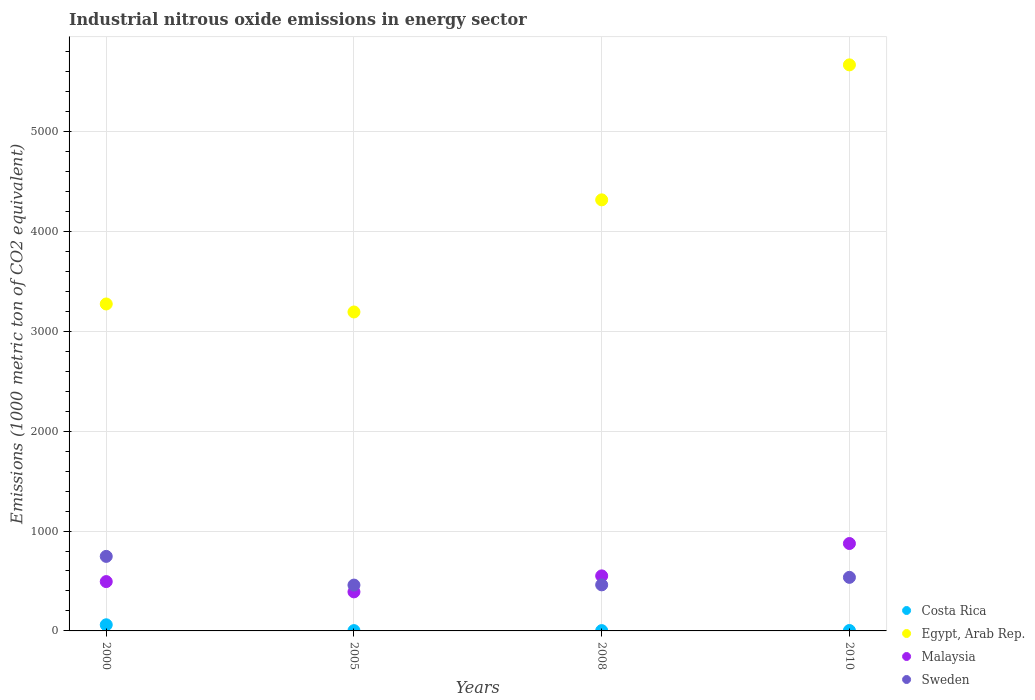How many different coloured dotlines are there?
Provide a short and direct response. 4. What is the amount of industrial nitrous oxide emitted in Egypt, Arab Rep. in 2005?
Offer a very short reply. 3192.6. Across all years, what is the maximum amount of industrial nitrous oxide emitted in Malaysia?
Ensure brevity in your answer.  874.9. Across all years, what is the minimum amount of industrial nitrous oxide emitted in Malaysia?
Provide a short and direct response. 390.9. In which year was the amount of industrial nitrous oxide emitted in Costa Rica minimum?
Your response must be concise. 2005. What is the total amount of industrial nitrous oxide emitted in Malaysia in the graph?
Offer a terse response. 2310.6. What is the difference between the amount of industrial nitrous oxide emitted in Egypt, Arab Rep. in 2000 and that in 2010?
Your answer should be very brief. -2393.5. What is the difference between the amount of industrial nitrous oxide emitted in Egypt, Arab Rep. in 2000 and the amount of industrial nitrous oxide emitted in Costa Rica in 2005?
Provide a short and direct response. 3269.6. What is the average amount of industrial nitrous oxide emitted in Sweden per year?
Your response must be concise. 550.55. In the year 2000, what is the difference between the amount of industrial nitrous oxide emitted in Egypt, Arab Rep. and amount of industrial nitrous oxide emitted in Sweden?
Ensure brevity in your answer.  2526.6. What is the ratio of the amount of industrial nitrous oxide emitted in Sweden in 2005 to that in 2010?
Offer a very short reply. 0.86. Is the amount of industrial nitrous oxide emitted in Sweden in 2000 less than that in 2005?
Offer a terse response. No. What is the difference between the highest and the second highest amount of industrial nitrous oxide emitted in Malaysia?
Offer a very short reply. 323.9. What is the difference between the highest and the lowest amount of industrial nitrous oxide emitted in Egypt, Arab Rep.?
Offer a terse response. 2473.6. Does the amount of industrial nitrous oxide emitted in Sweden monotonically increase over the years?
Make the answer very short. No. Is the amount of industrial nitrous oxide emitted in Costa Rica strictly greater than the amount of industrial nitrous oxide emitted in Egypt, Arab Rep. over the years?
Offer a terse response. No. What is the difference between two consecutive major ticks on the Y-axis?
Provide a succinct answer. 1000. Are the values on the major ticks of Y-axis written in scientific E-notation?
Ensure brevity in your answer.  No. Does the graph contain grids?
Make the answer very short. Yes. How are the legend labels stacked?
Your response must be concise. Vertical. What is the title of the graph?
Your response must be concise. Industrial nitrous oxide emissions in energy sector. What is the label or title of the Y-axis?
Give a very brief answer. Emissions (1000 metric ton of CO2 equivalent). What is the Emissions (1000 metric ton of CO2 equivalent) of Costa Rica in 2000?
Ensure brevity in your answer.  61.4. What is the Emissions (1000 metric ton of CO2 equivalent) of Egypt, Arab Rep. in 2000?
Give a very brief answer. 3272.7. What is the Emissions (1000 metric ton of CO2 equivalent) of Malaysia in 2000?
Provide a succinct answer. 493.8. What is the Emissions (1000 metric ton of CO2 equivalent) in Sweden in 2000?
Your answer should be very brief. 746.1. What is the Emissions (1000 metric ton of CO2 equivalent) of Egypt, Arab Rep. in 2005?
Your response must be concise. 3192.6. What is the Emissions (1000 metric ton of CO2 equivalent) of Malaysia in 2005?
Ensure brevity in your answer.  390.9. What is the Emissions (1000 metric ton of CO2 equivalent) in Sweden in 2005?
Give a very brief answer. 458.8. What is the Emissions (1000 metric ton of CO2 equivalent) in Egypt, Arab Rep. in 2008?
Keep it short and to the point. 4315. What is the Emissions (1000 metric ton of CO2 equivalent) in Malaysia in 2008?
Give a very brief answer. 551. What is the Emissions (1000 metric ton of CO2 equivalent) in Sweden in 2008?
Ensure brevity in your answer.  461.1. What is the Emissions (1000 metric ton of CO2 equivalent) in Costa Rica in 2010?
Give a very brief answer. 4.2. What is the Emissions (1000 metric ton of CO2 equivalent) in Egypt, Arab Rep. in 2010?
Keep it short and to the point. 5666.2. What is the Emissions (1000 metric ton of CO2 equivalent) in Malaysia in 2010?
Provide a succinct answer. 874.9. What is the Emissions (1000 metric ton of CO2 equivalent) of Sweden in 2010?
Ensure brevity in your answer.  536.2. Across all years, what is the maximum Emissions (1000 metric ton of CO2 equivalent) in Costa Rica?
Offer a terse response. 61.4. Across all years, what is the maximum Emissions (1000 metric ton of CO2 equivalent) of Egypt, Arab Rep.?
Keep it short and to the point. 5666.2. Across all years, what is the maximum Emissions (1000 metric ton of CO2 equivalent) in Malaysia?
Make the answer very short. 874.9. Across all years, what is the maximum Emissions (1000 metric ton of CO2 equivalent) in Sweden?
Provide a succinct answer. 746.1. Across all years, what is the minimum Emissions (1000 metric ton of CO2 equivalent) of Egypt, Arab Rep.?
Your answer should be compact. 3192.6. Across all years, what is the minimum Emissions (1000 metric ton of CO2 equivalent) in Malaysia?
Offer a very short reply. 390.9. Across all years, what is the minimum Emissions (1000 metric ton of CO2 equivalent) of Sweden?
Keep it short and to the point. 458.8. What is the total Emissions (1000 metric ton of CO2 equivalent) in Costa Rica in the graph?
Offer a very short reply. 71.8. What is the total Emissions (1000 metric ton of CO2 equivalent) of Egypt, Arab Rep. in the graph?
Your answer should be compact. 1.64e+04. What is the total Emissions (1000 metric ton of CO2 equivalent) in Malaysia in the graph?
Offer a terse response. 2310.6. What is the total Emissions (1000 metric ton of CO2 equivalent) in Sweden in the graph?
Keep it short and to the point. 2202.2. What is the difference between the Emissions (1000 metric ton of CO2 equivalent) of Costa Rica in 2000 and that in 2005?
Give a very brief answer. 58.3. What is the difference between the Emissions (1000 metric ton of CO2 equivalent) in Egypt, Arab Rep. in 2000 and that in 2005?
Make the answer very short. 80.1. What is the difference between the Emissions (1000 metric ton of CO2 equivalent) in Malaysia in 2000 and that in 2005?
Make the answer very short. 102.9. What is the difference between the Emissions (1000 metric ton of CO2 equivalent) in Sweden in 2000 and that in 2005?
Your response must be concise. 287.3. What is the difference between the Emissions (1000 metric ton of CO2 equivalent) in Costa Rica in 2000 and that in 2008?
Your answer should be compact. 58.3. What is the difference between the Emissions (1000 metric ton of CO2 equivalent) in Egypt, Arab Rep. in 2000 and that in 2008?
Make the answer very short. -1042.3. What is the difference between the Emissions (1000 metric ton of CO2 equivalent) of Malaysia in 2000 and that in 2008?
Keep it short and to the point. -57.2. What is the difference between the Emissions (1000 metric ton of CO2 equivalent) of Sweden in 2000 and that in 2008?
Your response must be concise. 285. What is the difference between the Emissions (1000 metric ton of CO2 equivalent) in Costa Rica in 2000 and that in 2010?
Ensure brevity in your answer.  57.2. What is the difference between the Emissions (1000 metric ton of CO2 equivalent) of Egypt, Arab Rep. in 2000 and that in 2010?
Offer a very short reply. -2393.5. What is the difference between the Emissions (1000 metric ton of CO2 equivalent) of Malaysia in 2000 and that in 2010?
Your response must be concise. -381.1. What is the difference between the Emissions (1000 metric ton of CO2 equivalent) of Sweden in 2000 and that in 2010?
Offer a very short reply. 209.9. What is the difference between the Emissions (1000 metric ton of CO2 equivalent) in Costa Rica in 2005 and that in 2008?
Offer a very short reply. 0. What is the difference between the Emissions (1000 metric ton of CO2 equivalent) in Egypt, Arab Rep. in 2005 and that in 2008?
Provide a succinct answer. -1122.4. What is the difference between the Emissions (1000 metric ton of CO2 equivalent) in Malaysia in 2005 and that in 2008?
Your response must be concise. -160.1. What is the difference between the Emissions (1000 metric ton of CO2 equivalent) of Sweden in 2005 and that in 2008?
Ensure brevity in your answer.  -2.3. What is the difference between the Emissions (1000 metric ton of CO2 equivalent) of Egypt, Arab Rep. in 2005 and that in 2010?
Provide a short and direct response. -2473.6. What is the difference between the Emissions (1000 metric ton of CO2 equivalent) of Malaysia in 2005 and that in 2010?
Your response must be concise. -484. What is the difference between the Emissions (1000 metric ton of CO2 equivalent) in Sweden in 2005 and that in 2010?
Your answer should be very brief. -77.4. What is the difference between the Emissions (1000 metric ton of CO2 equivalent) in Costa Rica in 2008 and that in 2010?
Make the answer very short. -1.1. What is the difference between the Emissions (1000 metric ton of CO2 equivalent) of Egypt, Arab Rep. in 2008 and that in 2010?
Ensure brevity in your answer.  -1351.2. What is the difference between the Emissions (1000 metric ton of CO2 equivalent) in Malaysia in 2008 and that in 2010?
Provide a short and direct response. -323.9. What is the difference between the Emissions (1000 metric ton of CO2 equivalent) in Sweden in 2008 and that in 2010?
Offer a terse response. -75.1. What is the difference between the Emissions (1000 metric ton of CO2 equivalent) of Costa Rica in 2000 and the Emissions (1000 metric ton of CO2 equivalent) of Egypt, Arab Rep. in 2005?
Provide a short and direct response. -3131.2. What is the difference between the Emissions (1000 metric ton of CO2 equivalent) of Costa Rica in 2000 and the Emissions (1000 metric ton of CO2 equivalent) of Malaysia in 2005?
Your answer should be compact. -329.5. What is the difference between the Emissions (1000 metric ton of CO2 equivalent) of Costa Rica in 2000 and the Emissions (1000 metric ton of CO2 equivalent) of Sweden in 2005?
Your response must be concise. -397.4. What is the difference between the Emissions (1000 metric ton of CO2 equivalent) of Egypt, Arab Rep. in 2000 and the Emissions (1000 metric ton of CO2 equivalent) of Malaysia in 2005?
Give a very brief answer. 2881.8. What is the difference between the Emissions (1000 metric ton of CO2 equivalent) of Egypt, Arab Rep. in 2000 and the Emissions (1000 metric ton of CO2 equivalent) of Sweden in 2005?
Ensure brevity in your answer.  2813.9. What is the difference between the Emissions (1000 metric ton of CO2 equivalent) in Malaysia in 2000 and the Emissions (1000 metric ton of CO2 equivalent) in Sweden in 2005?
Provide a succinct answer. 35. What is the difference between the Emissions (1000 metric ton of CO2 equivalent) of Costa Rica in 2000 and the Emissions (1000 metric ton of CO2 equivalent) of Egypt, Arab Rep. in 2008?
Offer a very short reply. -4253.6. What is the difference between the Emissions (1000 metric ton of CO2 equivalent) in Costa Rica in 2000 and the Emissions (1000 metric ton of CO2 equivalent) in Malaysia in 2008?
Give a very brief answer. -489.6. What is the difference between the Emissions (1000 metric ton of CO2 equivalent) of Costa Rica in 2000 and the Emissions (1000 metric ton of CO2 equivalent) of Sweden in 2008?
Your answer should be very brief. -399.7. What is the difference between the Emissions (1000 metric ton of CO2 equivalent) in Egypt, Arab Rep. in 2000 and the Emissions (1000 metric ton of CO2 equivalent) in Malaysia in 2008?
Provide a short and direct response. 2721.7. What is the difference between the Emissions (1000 metric ton of CO2 equivalent) in Egypt, Arab Rep. in 2000 and the Emissions (1000 metric ton of CO2 equivalent) in Sweden in 2008?
Ensure brevity in your answer.  2811.6. What is the difference between the Emissions (1000 metric ton of CO2 equivalent) in Malaysia in 2000 and the Emissions (1000 metric ton of CO2 equivalent) in Sweden in 2008?
Your response must be concise. 32.7. What is the difference between the Emissions (1000 metric ton of CO2 equivalent) in Costa Rica in 2000 and the Emissions (1000 metric ton of CO2 equivalent) in Egypt, Arab Rep. in 2010?
Offer a terse response. -5604.8. What is the difference between the Emissions (1000 metric ton of CO2 equivalent) in Costa Rica in 2000 and the Emissions (1000 metric ton of CO2 equivalent) in Malaysia in 2010?
Offer a very short reply. -813.5. What is the difference between the Emissions (1000 metric ton of CO2 equivalent) in Costa Rica in 2000 and the Emissions (1000 metric ton of CO2 equivalent) in Sweden in 2010?
Your answer should be compact. -474.8. What is the difference between the Emissions (1000 metric ton of CO2 equivalent) in Egypt, Arab Rep. in 2000 and the Emissions (1000 metric ton of CO2 equivalent) in Malaysia in 2010?
Give a very brief answer. 2397.8. What is the difference between the Emissions (1000 metric ton of CO2 equivalent) of Egypt, Arab Rep. in 2000 and the Emissions (1000 metric ton of CO2 equivalent) of Sweden in 2010?
Your answer should be compact. 2736.5. What is the difference between the Emissions (1000 metric ton of CO2 equivalent) in Malaysia in 2000 and the Emissions (1000 metric ton of CO2 equivalent) in Sweden in 2010?
Offer a very short reply. -42.4. What is the difference between the Emissions (1000 metric ton of CO2 equivalent) of Costa Rica in 2005 and the Emissions (1000 metric ton of CO2 equivalent) of Egypt, Arab Rep. in 2008?
Make the answer very short. -4311.9. What is the difference between the Emissions (1000 metric ton of CO2 equivalent) of Costa Rica in 2005 and the Emissions (1000 metric ton of CO2 equivalent) of Malaysia in 2008?
Ensure brevity in your answer.  -547.9. What is the difference between the Emissions (1000 metric ton of CO2 equivalent) in Costa Rica in 2005 and the Emissions (1000 metric ton of CO2 equivalent) in Sweden in 2008?
Offer a very short reply. -458. What is the difference between the Emissions (1000 metric ton of CO2 equivalent) of Egypt, Arab Rep. in 2005 and the Emissions (1000 metric ton of CO2 equivalent) of Malaysia in 2008?
Give a very brief answer. 2641.6. What is the difference between the Emissions (1000 metric ton of CO2 equivalent) in Egypt, Arab Rep. in 2005 and the Emissions (1000 metric ton of CO2 equivalent) in Sweden in 2008?
Give a very brief answer. 2731.5. What is the difference between the Emissions (1000 metric ton of CO2 equivalent) in Malaysia in 2005 and the Emissions (1000 metric ton of CO2 equivalent) in Sweden in 2008?
Keep it short and to the point. -70.2. What is the difference between the Emissions (1000 metric ton of CO2 equivalent) in Costa Rica in 2005 and the Emissions (1000 metric ton of CO2 equivalent) in Egypt, Arab Rep. in 2010?
Offer a very short reply. -5663.1. What is the difference between the Emissions (1000 metric ton of CO2 equivalent) of Costa Rica in 2005 and the Emissions (1000 metric ton of CO2 equivalent) of Malaysia in 2010?
Your answer should be compact. -871.8. What is the difference between the Emissions (1000 metric ton of CO2 equivalent) of Costa Rica in 2005 and the Emissions (1000 metric ton of CO2 equivalent) of Sweden in 2010?
Your answer should be very brief. -533.1. What is the difference between the Emissions (1000 metric ton of CO2 equivalent) of Egypt, Arab Rep. in 2005 and the Emissions (1000 metric ton of CO2 equivalent) of Malaysia in 2010?
Keep it short and to the point. 2317.7. What is the difference between the Emissions (1000 metric ton of CO2 equivalent) of Egypt, Arab Rep. in 2005 and the Emissions (1000 metric ton of CO2 equivalent) of Sweden in 2010?
Keep it short and to the point. 2656.4. What is the difference between the Emissions (1000 metric ton of CO2 equivalent) in Malaysia in 2005 and the Emissions (1000 metric ton of CO2 equivalent) in Sweden in 2010?
Give a very brief answer. -145.3. What is the difference between the Emissions (1000 metric ton of CO2 equivalent) of Costa Rica in 2008 and the Emissions (1000 metric ton of CO2 equivalent) of Egypt, Arab Rep. in 2010?
Give a very brief answer. -5663.1. What is the difference between the Emissions (1000 metric ton of CO2 equivalent) of Costa Rica in 2008 and the Emissions (1000 metric ton of CO2 equivalent) of Malaysia in 2010?
Your response must be concise. -871.8. What is the difference between the Emissions (1000 metric ton of CO2 equivalent) in Costa Rica in 2008 and the Emissions (1000 metric ton of CO2 equivalent) in Sweden in 2010?
Your answer should be very brief. -533.1. What is the difference between the Emissions (1000 metric ton of CO2 equivalent) of Egypt, Arab Rep. in 2008 and the Emissions (1000 metric ton of CO2 equivalent) of Malaysia in 2010?
Provide a short and direct response. 3440.1. What is the difference between the Emissions (1000 metric ton of CO2 equivalent) of Egypt, Arab Rep. in 2008 and the Emissions (1000 metric ton of CO2 equivalent) of Sweden in 2010?
Keep it short and to the point. 3778.8. What is the average Emissions (1000 metric ton of CO2 equivalent) in Costa Rica per year?
Offer a terse response. 17.95. What is the average Emissions (1000 metric ton of CO2 equivalent) of Egypt, Arab Rep. per year?
Your response must be concise. 4111.62. What is the average Emissions (1000 metric ton of CO2 equivalent) of Malaysia per year?
Keep it short and to the point. 577.65. What is the average Emissions (1000 metric ton of CO2 equivalent) in Sweden per year?
Keep it short and to the point. 550.55. In the year 2000, what is the difference between the Emissions (1000 metric ton of CO2 equivalent) of Costa Rica and Emissions (1000 metric ton of CO2 equivalent) of Egypt, Arab Rep.?
Ensure brevity in your answer.  -3211.3. In the year 2000, what is the difference between the Emissions (1000 metric ton of CO2 equivalent) of Costa Rica and Emissions (1000 metric ton of CO2 equivalent) of Malaysia?
Your answer should be very brief. -432.4. In the year 2000, what is the difference between the Emissions (1000 metric ton of CO2 equivalent) in Costa Rica and Emissions (1000 metric ton of CO2 equivalent) in Sweden?
Ensure brevity in your answer.  -684.7. In the year 2000, what is the difference between the Emissions (1000 metric ton of CO2 equivalent) in Egypt, Arab Rep. and Emissions (1000 metric ton of CO2 equivalent) in Malaysia?
Provide a succinct answer. 2778.9. In the year 2000, what is the difference between the Emissions (1000 metric ton of CO2 equivalent) in Egypt, Arab Rep. and Emissions (1000 metric ton of CO2 equivalent) in Sweden?
Provide a short and direct response. 2526.6. In the year 2000, what is the difference between the Emissions (1000 metric ton of CO2 equivalent) of Malaysia and Emissions (1000 metric ton of CO2 equivalent) of Sweden?
Your response must be concise. -252.3. In the year 2005, what is the difference between the Emissions (1000 metric ton of CO2 equivalent) in Costa Rica and Emissions (1000 metric ton of CO2 equivalent) in Egypt, Arab Rep.?
Your response must be concise. -3189.5. In the year 2005, what is the difference between the Emissions (1000 metric ton of CO2 equivalent) in Costa Rica and Emissions (1000 metric ton of CO2 equivalent) in Malaysia?
Keep it short and to the point. -387.8. In the year 2005, what is the difference between the Emissions (1000 metric ton of CO2 equivalent) of Costa Rica and Emissions (1000 metric ton of CO2 equivalent) of Sweden?
Your response must be concise. -455.7. In the year 2005, what is the difference between the Emissions (1000 metric ton of CO2 equivalent) in Egypt, Arab Rep. and Emissions (1000 metric ton of CO2 equivalent) in Malaysia?
Give a very brief answer. 2801.7. In the year 2005, what is the difference between the Emissions (1000 metric ton of CO2 equivalent) of Egypt, Arab Rep. and Emissions (1000 metric ton of CO2 equivalent) of Sweden?
Provide a succinct answer. 2733.8. In the year 2005, what is the difference between the Emissions (1000 metric ton of CO2 equivalent) of Malaysia and Emissions (1000 metric ton of CO2 equivalent) of Sweden?
Ensure brevity in your answer.  -67.9. In the year 2008, what is the difference between the Emissions (1000 metric ton of CO2 equivalent) of Costa Rica and Emissions (1000 metric ton of CO2 equivalent) of Egypt, Arab Rep.?
Provide a succinct answer. -4311.9. In the year 2008, what is the difference between the Emissions (1000 metric ton of CO2 equivalent) in Costa Rica and Emissions (1000 metric ton of CO2 equivalent) in Malaysia?
Offer a very short reply. -547.9. In the year 2008, what is the difference between the Emissions (1000 metric ton of CO2 equivalent) in Costa Rica and Emissions (1000 metric ton of CO2 equivalent) in Sweden?
Offer a very short reply. -458. In the year 2008, what is the difference between the Emissions (1000 metric ton of CO2 equivalent) in Egypt, Arab Rep. and Emissions (1000 metric ton of CO2 equivalent) in Malaysia?
Provide a succinct answer. 3764. In the year 2008, what is the difference between the Emissions (1000 metric ton of CO2 equivalent) of Egypt, Arab Rep. and Emissions (1000 metric ton of CO2 equivalent) of Sweden?
Keep it short and to the point. 3853.9. In the year 2008, what is the difference between the Emissions (1000 metric ton of CO2 equivalent) in Malaysia and Emissions (1000 metric ton of CO2 equivalent) in Sweden?
Provide a succinct answer. 89.9. In the year 2010, what is the difference between the Emissions (1000 metric ton of CO2 equivalent) of Costa Rica and Emissions (1000 metric ton of CO2 equivalent) of Egypt, Arab Rep.?
Provide a succinct answer. -5662. In the year 2010, what is the difference between the Emissions (1000 metric ton of CO2 equivalent) of Costa Rica and Emissions (1000 metric ton of CO2 equivalent) of Malaysia?
Offer a terse response. -870.7. In the year 2010, what is the difference between the Emissions (1000 metric ton of CO2 equivalent) in Costa Rica and Emissions (1000 metric ton of CO2 equivalent) in Sweden?
Your answer should be very brief. -532. In the year 2010, what is the difference between the Emissions (1000 metric ton of CO2 equivalent) of Egypt, Arab Rep. and Emissions (1000 metric ton of CO2 equivalent) of Malaysia?
Ensure brevity in your answer.  4791.3. In the year 2010, what is the difference between the Emissions (1000 metric ton of CO2 equivalent) in Egypt, Arab Rep. and Emissions (1000 metric ton of CO2 equivalent) in Sweden?
Give a very brief answer. 5130. In the year 2010, what is the difference between the Emissions (1000 metric ton of CO2 equivalent) of Malaysia and Emissions (1000 metric ton of CO2 equivalent) of Sweden?
Give a very brief answer. 338.7. What is the ratio of the Emissions (1000 metric ton of CO2 equivalent) in Costa Rica in 2000 to that in 2005?
Your response must be concise. 19.81. What is the ratio of the Emissions (1000 metric ton of CO2 equivalent) of Egypt, Arab Rep. in 2000 to that in 2005?
Your response must be concise. 1.03. What is the ratio of the Emissions (1000 metric ton of CO2 equivalent) of Malaysia in 2000 to that in 2005?
Make the answer very short. 1.26. What is the ratio of the Emissions (1000 metric ton of CO2 equivalent) in Sweden in 2000 to that in 2005?
Your answer should be compact. 1.63. What is the ratio of the Emissions (1000 metric ton of CO2 equivalent) in Costa Rica in 2000 to that in 2008?
Ensure brevity in your answer.  19.81. What is the ratio of the Emissions (1000 metric ton of CO2 equivalent) in Egypt, Arab Rep. in 2000 to that in 2008?
Make the answer very short. 0.76. What is the ratio of the Emissions (1000 metric ton of CO2 equivalent) in Malaysia in 2000 to that in 2008?
Ensure brevity in your answer.  0.9. What is the ratio of the Emissions (1000 metric ton of CO2 equivalent) in Sweden in 2000 to that in 2008?
Provide a short and direct response. 1.62. What is the ratio of the Emissions (1000 metric ton of CO2 equivalent) of Costa Rica in 2000 to that in 2010?
Ensure brevity in your answer.  14.62. What is the ratio of the Emissions (1000 metric ton of CO2 equivalent) of Egypt, Arab Rep. in 2000 to that in 2010?
Your response must be concise. 0.58. What is the ratio of the Emissions (1000 metric ton of CO2 equivalent) of Malaysia in 2000 to that in 2010?
Offer a terse response. 0.56. What is the ratio of the Emissions (1000 metric ton of CO2 equivalent) in Sweden in 2000 to that in 2010?
Make the answer very short. 1.39. What is the ratio of the Emissions (1000 metric ton of CO2 equivalent) in Egypt, Arab Rep. in 2005 to that in 2008?
Keep it short and to the point. 0.74. What is the ratio of the Emissions (1000 metric ton of CO2 equivalent) of Malaysia in 2005 to that in 2008?
Provide a short and direct response. 0.71. What is the ratio of the Emissions (1000 metric ton of CO2 equivalent) of Sweden in 2005 to that in 2008?
Your answer should be very brief. 0.99. What is the ratio of the Emissions (1000 metric ton of CO2 equivalent) in Costa Rica in 2005 to that in 2010?
Give a very brief answer. 0.74. What is the ratio of the Emissions (1000 metric ton of CO2 equivalent) of Egypt, Arab Rep. in 2005 to that in 2010?
Offer a terse response. 0.56. What is the ratio of the Emissions (1000 metric ton of CO2 equivalent) of Malaysia in 2005 to that in 2010?
Offer a terse response. 0.45. What is the ratio of the Emissions (1000 metric ton of CO2 equivalent) in Sweden in 2005 to that in 2010?
Provide a short and direct response. 0.86. What is the ratio of the Emissions (1000 metric ton of CO2 equivalent) in Costa Rica in 2008 to that in 2010?
Your response must be concise. 0.74. What is the ratio of the Emissions (1000 metric ton of CO2 equivalent) of Egypt, Arab Rep. in 2008 to that in 2010?
Keep it short and to the point. 0.76. What is the ratio of the Emissions (1000 metric ton of CO2 equivalent) of Malaysia in 2008 to that in 2010?
Your answer should be compact. 0.63. What is the ratio of the Emissions (1000 metric ton of CO2 equivalent) in Sweden in 2008 to that in 2010?
Ensure brevity in your answer.  0.86. What is the difference between the highest and the second highest Emissions (1000 metric ton of CO2 equivalent) of Costa Rica?
Offer a very short reply. 57.2. What is the difference between the highest and the second highest Emissions (1000 metric ton of CO2 equivalent) in Egypt, Arab Rep.?
Ensure brevity in your answer.  1351.2. What is the difference between the highest and the second highest Emissions (1000 metric ton of CO2 equivalent) in Malaysia?
Offer a terse response. 323.9. What is the difference between the highest and the second highest Emissions (1000 metric ton of CO2 equivalent) of Sweden?
Offer a very short reply. 209.9. What is the difference between the highest and the lowest Emissions (1000 metric ton of CO2 equivalent) of Costa Rica?
Offer a terse response. 58.3. What is the difference between the highest and the lowest Emissions (1000 metric ton of CO2 equivalent) in Egypt, Arab Rep.?
Ensure brevity in your answer.  2473.6. What is the difference between the highest and the lowest Emissions (1000 metric ton of CO2 equivalent) of Malaysia?
Ensure brevity in your answer.  484. What is the difference between the highest and the lowest Emissions (1000 metric ton of CO2 equivalent) of Sweden?
Make the answer very short. 287.3. 